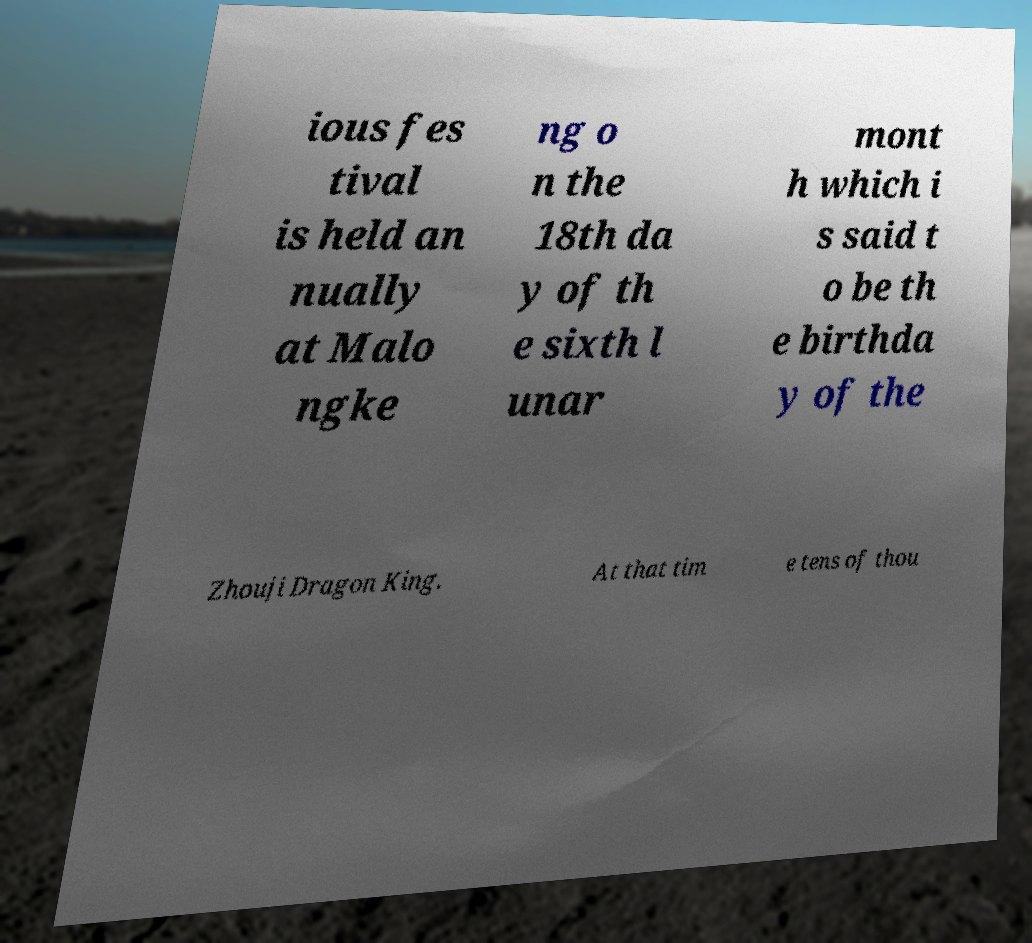Please identify and transcribe the text found in this image. ious fes tival is held an nually at Malo ngke ng o n the 18th da y of th e sixth l unar mont h which i s said t o be th e birthda y of the Zhouji Dragon King. At that tim e tens of thou 